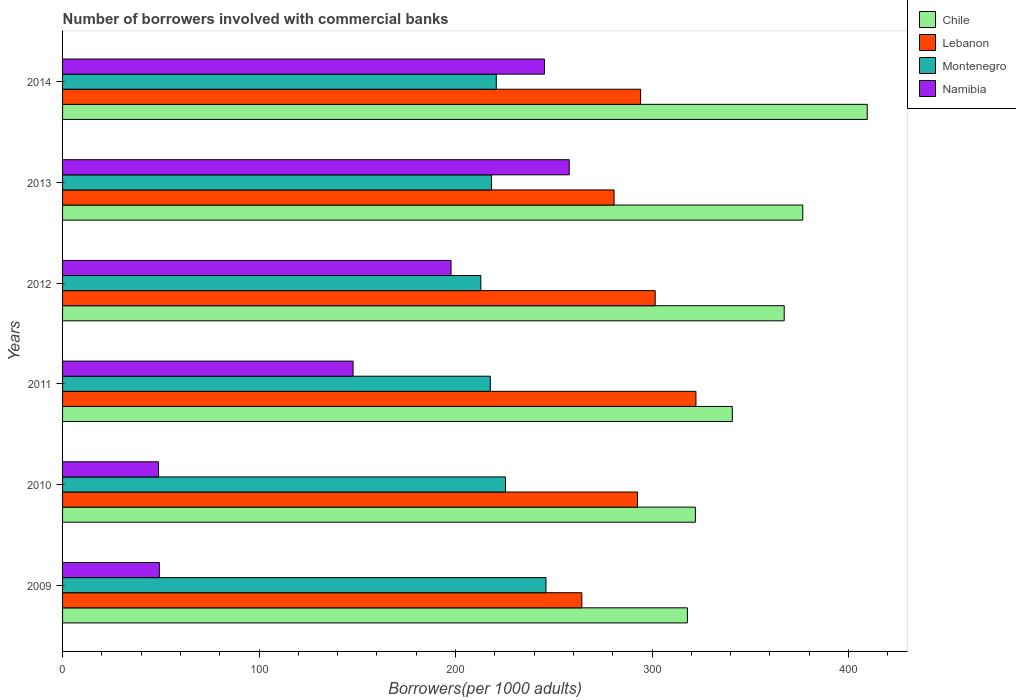How many different coloured bars are there?
Give a very brief answer. 4. Are the number of bars on each tick of the Y-axis equal?
Ensure brevity in your answer.  Yes. How many bars are there on the 2nd tick from the top?
Your answer should be very brief. 4. In how many cases, is the number of bars for a given year not equal to the number of legend labels?
Offer a very short reply. 0. What is the number of borrowers involved with commercial banks in Chile in 2013?
Keep it short and to the point. 376.7. Across all years, what is the maximum number of borrowers involved with commercial banks in Montenegro?
Offer a terse response. 246.02. Across all years, what is the minimum number of borrowers involved with commercial banks in Chile?
Make the answer very short. 317.99. What is the total number of borrowers involved with commercial banks in Lebanon in the graph?
Give a very brief answer. 1755.56. What is the difference between the number of borrowers involved with commercial banks in Montenegro in 2010 and that in 2014?
Provide a short and direct response. 4.68. What is the difference between the number of borrowers involved with commercial banks in Montenegro in 2010 and the number of borrowers involved with commercial banks in Lebanon in 2014?
Give a very brief answer. -68.76. What is the average number of borrowers involved with commercial banks in Montenegro per year?
Keep it short and to the point. 223.5. In the year 2014, what is the difference between the number of borrowers involved with commercial banks in Namibia and number of borrowers involved with commercial banks in Montenegro?
Provide a short and direct response. 24.52. In how many years, is the number of borrowers involved with commercial banks in Lebanon greater than 340 ?
Keep it short and to the point. 0. What is the ratio of the number of borrowers involved with commercial banks in Chile in 2010 to that in 2012?
Offer a very short reply. 0.88. Is the number of borrowers involved with commercial banks in Namibia in 2012 less than that in 2013?
Keep it short and to the point. Yes. Is the difference between the number of borrowers involved with commercial banks in Namibia in 2011 and 2014 greater than the difference between the number of borrowers involved with commercial banks in Montenegro in 2011 and 2014?
Your answer should be compact. No. What is the difference between the highest and the second highest number of borrowers involved with commercial banks in Lebanon?
Your answer should be compact. 20.74. What is the difference between the highest and the lowest number of borrowers involved with commercial banks in Montenegro?
Give a very brief answer. 33.16. Is it the case that in every year, the sum of the number of borrowers involved with commercial banks in Namibia and number of borrowers involved with commercial banks in Montenegro is greater than the sum of number of borrowers involved with commercial banks in Lebanon and number of borrowers involved with commercial banks in Chile?
Ensure brevity in your answer.  No. What does the 3rd bar from the top in 2012 represents?
Provide a succinct answer. Lebanon. What does the 3rd bar from the bottom in 2012 represents?
Provide a short and direct response. Montenegro. Is it the case that in every year, the sum of the number of borrowers involved with commercial banks in Lebanon and number of borrowers involved with commercial banks in Namibia is greater than the number of borrowers involved with commercial banks in Montenegro?
Offer a very short reply. Yes. What is the difference between two consecutive major ticks on the X-axis?
Your answer should be very brief. 100. Are the values on the major ticks of X-axis written in scientific E-notation?
Ensure brevity in your answer.  No. Does the graph contain any zero values?
Provide a short and direct response. No. Where does the legend appear in the graph?
Your response must be concise. Top right. What is the title of the graph?
Make the answer very short. Number of borrowers involved with commercial banks. What is the label or title of the X-axis?
Keep it short and to the point. Borrowers(per 1000 adults). What is the label or title of the Y-axis?
Provide a short and direct response. Years. What is the Borrowers(per 1000 adults) in Chile in 2009?
Keep it short and to the point. 317.99. What is the Borrowers(per 1000 adults) of Lebanon in 2009?
Offer a terse response. 264.25. What is the Borrowers(per 1000 adults) in Montenegro in 2009?
Your response must be concise. 246.02. What is the Borrowers(per 1000 adults) of Namibia in 2009?
Make the answer very short. 49.25. What is the Borrowers(per 1000 adults) in Chile in 2010?
Your answer should be very brief. 322.03. What is the Borrowers(per 1000 adults) of Lebanon in 2010?
Your answer should be compact. 292.58. What is the Borrowers(per 1000 adults) in Montenegro in 2010?
Your answer should be very brief. 225.41. What is the Borrowers(per 1000 adults) in Namibia in 2010?
Keep it short and to the point. 48.85. What is the Borrowers(per 1000 adults) of Chile in 2011?
Make the answer very short. 340.83. What is the Borrowers(per 1000 adults) in Lebanon in 2011?
Offer a very short reply. 322.32. What is the Borrowers(per 1000 adults) in Montenegro in 2011?
Your answer should be compact. 217.69. What is the Borrowers(per 1000 adults) of Namibia in 2011?
Your answer should be very brief. 147.84. What is the Borrowers(per 1000 adults) in Chile in 2012?
Provide a succinct answer. 367.24. What is the Borrowers(per 1000 adults) in Lebanon in 2012?
Offer a terse response. 301.58. What is the Borrowers(per 1000 adults) of Montenegro in 2012?
Provide a succinct answer. 212.85. What is the Borrowers(per 1000 adults) of Namibia in 2012?
Give a very brief answer. 197.69. What is the Borrowers(per 1000 adults) in Chile in 2013?
Your response must be concise. 376.7. What is the Borrowers(per 1000 adults) of Lebanon in 2013?
Give a very brief answer. 280.67. What is the Borrowers(per 1000 adults) in Montenegro in 2013?
Ensure brevity in your answer.  218.3. What is the Borrowers(per 1000 adults) of Namibia in 2013?
Keep it short and to the point. 257.84. What is the Borrowers(per 1000 adults) of Chile in 2014?
Make the answer very short. 409.51. What is the Borrowers(per 1000 adults) in Lebanon in 2014?
Make the answer very short. 294.17. What is the Borrowers(per 1000 adults) of Montenegro in 2014?
Offer a terse response. 220.72. What is the Borrowers(per 1000 adults) of Namibia in 2014?
Provide a short and direct response. 245.24. Across all years, what is the maximum Borrowers(per 1000 adults) of Chile?
Offer a terse response. 409.51. Across all years, what is the maximum Borrowers(per 1000 adults) in Lebanon?
Your response must be concise. 322.32. Across all years, what is the maximum Borrowers(per 1000 adults) of Montenegro?
Your answer should be very brief. 246.02. Across all years, what is the maximum Borrowers(per 1000 adults) of Namibia?
Your answer should be very brief. 257.84. Across all years, what is the minimum Borrowers(per 1000 adults) of Chile?
Give a very brief answer. 317.99. Across all years, what is the minimum Borrowers(per 1000 adults) in Lebanon?
Your answer should be very brief. 264.25. Across all years, what is the minimum Borrowers(per 1000 adults) in Montenegro?
Make the answer very short. 212.85. Across all years, what is the minimum Borrowers(per 1000 adults) of Namibia?
Your answer should be very brief. 48.85. What is the total Borrowers(per 1000 adults) in Chile in the graph?
Your response must be concise. 2134.3. What is the total Borrowers(per 1000 adults) of Lebanon in the graph?
Provide a succinct answer. 1755.56. What is the total Borrowers(per 1000 adults) of Montenegro in the graph?
Offer a terse response. 1340.98. What is the total Borrowers(per 1000 adults) in Namibia in the graph?
Offer a terse response. 946.71. What is the difference between the Borrowers(per 1000 adults) of Chile in 2009 and that in 2010?
Offer a very short reply. -4.04. What is the difference between the Borrowers(per 1000 adults) in Lebanon in 2009 and that in 2010?
Give a very brief answer. -28.33. What is the difference between the Borrowers(per 1000 adults) of Montenegro in 2009 and that in 2010?
Your answer should be compact. 20.61. What is the difference between the Borrowers(per 1000 adults) of Namibia in 2009 and that in 2010?
Provide a short and direct response. 0.4. What is the difference between the Borrowers(per 1000 adults) in Chile in 2009 and that in 2011?
Offer a terse response. -22.84. What is the difference between the Borrowers(per 1000 adults) in Lebanon in 2009 and that in 2011?
Offer a very short reply. -58.07. What is the difference between the Borrowers(per 1000 adults) in Montenegro in 2009 and that in 2011?
Offer a terse response. 28.33. What is the difference between the Borrowers(per 1000 adults) in Namibia in 2009 and that in 2011?
Your answer should be very brief. -98.59. What is the difference between the Borrowers(per 1000 adults) in Chile in 2009 and that in 2012?
Offer a very short reply. -49.25. What is the difference between the Borrowers(per 1000 adults) of Lebanon in 2009 and that in 2012?
Offer a very short reply. -37.33. What is the difference between the Borrowers(per 1000 adults) in Montenegro in 2009 and that in 2012?
Your response must be concise. 33.16. What is the difference between the Borrowers(per 1000 adults) of Namibia in 2009 and that in 2012?
Your answer should be very brief. -148.44. What is the difference between the Borrowers(per 1000 adults) in Chile in 2009 and that in 2013?
Ensure brevity in your answer.  -58.7. What is the difference between the Borrowers(per 1000 adults) in Lebanon in 2009 and that in 2013?
Provide a succinct answer. -16.42. What is the difference between the Borrowers(per 1000 adults) of Montenegro in 2009 and that in 2013?
Keep it short and to the point. 27.72. What is the difference between the Borrowers(per 1000 adults) of Namibia in 2009 and that in 2013?
Your answer should be compact. -208.59. What is the difference between the Borrowers(per 1000 adults) in Chile in 2009 and that in 2014?
Your response must be concise. -91.52. What is the difference between the Borrowers(per 1000 adults) in Lebanon in 2009 and that in 2014?
Your answer should be compact. -29.92. What is the difference between the Borrowers(per 1000 adults) in Montenegro in 2009 and that in 2014?
Offer a terse response. 25.29. What is the difference between the Borrowers(per 1000 adults) of Namibia in 2009 and that in 2014?
Your answer should be very brief. -195.99. What is the difference between the Borrowers(per 1000 adults) in Chile in 2010 and that in 2011?
Your response must be concise. -18.8. What is the difference between the Borrowers(per 1000 adults) of Lebanon in 2010 and that in 2011?
Make the answer very short. -29.74. What is the difference between the Borrowers(per 1000 adults) of Montenegro in 2010 and that in 2011?
Provide a short and direct response. 7.72. What is the difference between the Borrowers(per 1000 adults) in Namibia in 2010 and that in 2011?
Offer a terse response. -99. What is the difference between the Borrowers(per 1000 adults) in Chile in 2010 and that in 2012?
Provide a short and direct response. -45.21. What is the difference between the Borrowers(per 1000 adults) of Lebanon in 2010 and that in 2012?
Give a very brief answer. -9. What is the difference between the Borrowers(per 1000 adults) in Montenegro in 2010 and that in 2012?
Your response must be concise. 12.55. What is the difference between the Borrowers(per 1000 adults) of Namibia in 2010 and that in 2012?
Offer a very short reply. -148.84. What is the difference between the Borrowers(per 1000 adults) in Chile in 2010 and that in 2013?
Ensure brevity in your answer.  -54.66. What is the difference between the Borrowers(per 1000 adults) in Lebanon in 2010 and that in 2013?
Provide a succinct answer. 11.91. What is the difference between the Borrowers(per 1000 adults) of Montenegro in 2010 and that in 2013?
Provide a succinct answer. 7.11. What is the difference between the Borrowers(per 1000 adults) in Namibia in 2010 and that in 2013?
Make the answer very short. -208.99. What is the difference between the Borrowers(per 1000 adults) in Chile in 2010 and that in 2014?
Offer a very short reply. -87.47. What is the difference between the Borrowers(per 1000 adults) in Lebanon in 2010 and that in 2014?
Your answer should be compact. -1.59. What is the difference between the Borrowers(per 1000 adults) of Montenegro in 2010 and that in 2014?
Ensure brevity in your answer.  4.68. What is the difference between the Borrowers(per 1000 adults) of Namibia in 2010 and that in 2014?
Your answer should be very brief. -196.39. What is the difference between the Borrowers(per 1000 adults) of Chile in 2011 and that in 2012?
Your response must be concise. -26.41. What is the difference between the Borrowers(per 1000 adults) in Lebanon in 2011 and that in 2012?
Provide a succinct answer. 20.74. What is the difference between the Borrowers(per 1000 adults) in Montenegro in 2011 and that in 2012?
Offer a very short reply. 4.83. What is the difference between the Borrowers(per 1000 adults) of Namibia in 2011 and that in 2012?
Your answer should be compact. -49.85. What is the difference between the Borrowers(per 1000 adults) in Chile in 2011 and that in 2013?
Keep it short and to the point. -35.86. What is the difference between the Borrowers(per 1000 adults) of Lebanon in 2011 and that in 2013?
Provide a succinct answer. 41.65. What is the difference between the Borrowers(per 1000 adults) in Montenegro in 2011 and that in 2013?
Your answer should be very brief. -0.61. What is the difference between the Borrowers(per 1000 adults) in Namibia in 2011 and that in 2013?
Your answer should be very brief. -110. What is the difference between the Borrowers(per 1000 adults) of Chile in 2011 and that in 2014?
Make the answer very short. -68.67. What is the difference between the Borrowers(per 1000 adults) of Lebanon in 2011 and that in 2014?
Keep it short and to the point. 28.15. What is the difference between the Borrowers(per 1000 adults) in Montenegro in 2011 and that in 2014?
Provide a short and direct response. -3.03. What is the difference between the Borrowers(per 1000 adults) of Namibia in 2011 and that in 2014?
Provide a succinct answer. -97.39. What is the difference between the Borrowers(per 1000 adults) of Chile in 2012 and that in 2013?
Provide a succinct answer. -9.46. What is the difference between the Borrowers(per 1000 adults) of Lebanon in 2012 and that in 2013?
Your response must be concise. 20.91. What is the difference between the Borrowers(per 1000 adults) of Montenegro in 2012 and that in 2013?
Make the answer very short. -5.44. What is the difference between the Borrowers(per 1000 adults) in Namibia in 2012 and that in 2013?
Your answer should be very brief. -60.15. What is the difference between the Borrowers(per 1000 adults) in Chile in 2012 and that in 2014?
Provide a succinct answer. -42.27. What is the difference between the Borrowers(per 1000 adults) in Lebanon in 2012 and that in 2014?
Offer a terse response. 7.41. What is the difference between the Borrowers(per 1000 adults) of Montenegro in 2012 and that in 2014?
Offer a terse response. -7.87. What is the difference between the Borrowers(per 1000 adults) in Namibia in 2012 and that in 2014?
Ensure brevity in your answer.  -47.55. What is the difference between the Borrowers(per 1000 adults) in Chile in 2013 and that in 2014?
Provide a short and direct response. -32.81. What is the difference between the Borrowers(per 1000 adults) of Lebanon in 2013 and that in 2014?
Give a very brief answer. -13.5. What is the difference between the Borrowers(per 1000 adults) in Montenegro in 2013 and that in 2014?
Ensure brevity in your answer.  -2.42. What is the difference between the Borrowers(per 1000 adults) of Namibia in 2013 and that in 2014?
Provide a succinct answer. 12.6. What is the difference between the Borrowers(per 1000 adults) in Chile in 2009 and the Borrowers(per 1000 adults) in Lebanon in 2010?
Make the answer very short. 25.41. What is the difference between the Borrowers(per 1000 adults) of Chile in 2009 and the Borrowers(per 1000 adults) of Montenegro in 2010?
Your response must be concise. 92.59. What is the difference between the Borrowers(per 1000 adults) of Chile in 2009 and the Borrowers(per 1000 adults) of Namibia in 2010?
Your response must be concise. 269.14. What is the difference between the Borrowers(per 1000 adults) in Lebanon in 2009 and the Borrowers(per 1000 adults) in Montenegro in 2010?
Your answer should be compact. 38.84. What is the difference between the Borrowers(per 1000 adults) of Lebanon in 2009 and the Borrowers(per 1000 adults) of Namibia in 2010?
Your response must be concise. 215.4. What is the difference between the Borrowers(per 1000 adults) of Montenegro in 2009 and the Borrowers(per 1000 adults) of Namibia in 2010?
Your answer should be very brief. 197.17. What is the difference between the Borrowers(per 1000 adults) of Chile in 2009 and the Borrowers(per 1000 adults) of Lebanon in 2011?
Ensure brevity in your answer.  -4.33. What is the difference between the Borrowers(per 1000 adults) of Chile in 2009 and the Borrowers(per 1000 adults) of Montenegro in 2011?
Provide a succinct answer. 100.3. What is the difference between the Borrowers(per 1000 adults) of Chile in 2009 and the Borrowers(per 1000 adults) of Namibia in 2011?
Ensure brevity in your answer.  170.15. What is the difference between the Borrowers(per 1000 adults) in Lebanon in 2009 and the Borrowers(per 1000 adults) in Montenegro in 2011?
Offer a very short reply. 46.56. What is the difference between the Borrowers(per 1000 adults) of Lebanon in 2009 and the Borrowers(per 1000 adults) of Namibia in 2011?
Offer a terse response. 116.4. What is the difference between the Borrowers(per 1000 adults) in Montenegro in 2009 and the Borrowers(per 1000 adults) in Namibia in 2011?
Make the answer very short. 98.17. What is the difference between the Borrowers(per 1000 adults) of Chile in 2009 and the Borrowers(per 1000 adults) of Lebanon in 2012?
Ensure brevity in your answer.  16.41. What is the difference between the Borrowers(per 1000 adults) in Chile in 2009 and the Borrowers(per 1000 adults) in Montenegro in 2012?
Make the answer very short. 105.14. What is the difference between the Borrowers(per 1000 adults) of Chile in 2009 and the Borrowers(per 1000 adults) of Namibia in 2012?
Ensure brevity in your answer.  120.3. What is the difference between the Borrowers(per 1000 adults) of Lebanon in 2009 and the Borrowers(per 1000 adults) of Montenegro in 2012?
Make the answer very short. 51.39. What is the difference between the Borrowers(per 1000 adults) in Lebanon in 2009 and the Borrowers(per 1000 adults) in Namibia in 2012?
Ensure brevity in your answer.  66.56. What is the difference between the Borrowers(per 1000 adults) in Montenegro in 2009 and the Borrowers(per 1000 adults) in Namibia in 2012?
Ensure brevity in your answer.  48.33. What is the difference between the Borrowers(per 1000 adults) of Chile in 2009 and the Borrowers(per 1000 adults) of Lebanon in 2013?
Offer a terse response. 37.32. What is the difference between the Borrowers(per 1000 adults) of Chile in 2009 and the Borrowers(per 1000 adults) of Montenegro in 2013?
Provide a succinct answer. 99.69. What is the difference between the Borrowers(per 1000 adults) in Chile in 2009 and the Borrowers(per 1000 adults) in Namibia in 2013?
Ensure brevity in your answer.  60.15. What is the difference between the Borrowers(per 1000 adults) of Lebanon in 2009 and the Borrowers(per 1000 adults) of Montenegro in 2013?
Provide a short and direct response. 45.95. What is the difference between the Borrowers(per 1000 adults) of Lebanon in 2009 and the Borrowers(per 1000 adults) of Namibia in 2013?
Give a very brief answer. 6.41. What is the difference between the Borrowers(per 1000 adults) in Montenegro in 2009 and the Borrowers(per 1000 adults) in Namibia in 2013?
Ensure brevity in your answer.  -11.83. What is the difference between the Borrowers(per 1000 adults) of Chile in 2009 and the Borrowers(per 1000 adults) of Lebanon in 2014?
Ensure brevity in your answer.  23.82. What is the difference between the Borrowers(per 1000 adults) of Chile in 2009 and the Borrowers(per 1000 adults) of Montenegro in 2014?
Offer a terse response. 97.27. What is the difference between the Borrowers(per 1000 adults) of Chile in 2009 and the Borrowers(per 1000 adults) of Namibia in 2014?
Provide a short and direct response. 72.75. What is the difference between the Borrowers(per 1000 adults) in Lebanon in 2009 and the Borrowers(per 1000 adults) in Montenegro in 2014?
Provide a short and direct response. 43.53. What is the difference between the Borrowers(per 1000 adults) in Lebanon in 2009 and the Borrowers(per 1000 adults) in Namibia in 2014?
Your answer should be very brief. 19.01. What is the difference between the Borrowers(per 1000 adults) of Montenegro in 2009 and the Borrowers(per 1000 adults) of Namibia in 2014?
Keep it short and to the point. 0.78. What is the difference between the Borrowers(per 1000 adults) in Chile in 2010 and the Borrowers(per 1000 adults) in Lebanon in 2011?
Offer a terse response. -0.29. What is the difference between the Borrowers(per 1000 adults) in Chile in 2010 and the Borrowers(per 1000 adults) in Montenegro in 2011?
Provide a succinct answer. 104.35. What is the difference between the Borrowers(per 1000 adults) of Chile in 2010 and the Borrowers(per 1000 adults) of Namibia in 2011?
Make the answer very short. 174.19. What is the difference between the Borrowers(per 1000 adults) in Lebanon in 2010 and the Borrowers(per 1000 adults) in Montenegro in 2011?
Make the answer very short. 74.89. What is the difference between the Borrowers(per 1000 adults) of Lebanon in 2010 and the Borrowers(per 1000 adults) of Namibia in 2011?
Make the answer very short. 144.74. What is the difference between the Borrowers(per 1000 adults) in Montenegro in 2010 and the Borrowers(per 1000 adults) in Namibia in 2011?
Ensure brevity in your answer.  77.56. What is the difference between the Borrowers(per 1000 adults) in Chile in 2010 and the Borrowers(per 1000 adults) in Lebanon in 2012?
Your answer should be very brief. 20.45. What is the difference between the Borrowers(per 1000 adults) of Chile in 2010 and the Borrowers(per 1000 adults) of Montenegro in 2012?
Offer a terse response. 109.18. What is the difference between the Borrowers(per 1000 adults) in Chile in 2010 and the Borrowers(per 1000 adults) in Namibia in 2012?
Your response must be concise. 124.34. What is the difference between the Borrowers(per 1000 adults) of Lebanon in 2010 and the Borrowers(per 1000 adults) of Montenegro in 2012?
Your answer should be very brief. 79.73. What is the difference between the Borrowers(per 1000 adults) in Lebanon in 2010 and the Borrowers(per 1000 adults) in Namibia in 2012?
Provide a succinct answer. 94.89. What is the difference between the Borrowers(per 1000 adults) in Montenegro in 2010 and the Borrowers(per 1000 adults) in Namibia in 2012?
Your answer should be very brief. 27.72. What is the difference between the Borrowers(per 1000 adults) in Chile in 2010 and the Borrowers(per 1000 adults) in Lebanon in 2013?
Give a very brief answer. 41.37. What is the difference between the Borrowers(per 1000 adults) in Chile in 2010 and the Borrowers(per 1000 adults) in Montenegro in 2013?
Your answer should be compact. 103.73. What is the difference between the Borrowers(per 1000 adults) of Chile in 2010 and the Borrowers(per 1000 adults) of Namibia in 2013?
Ensure brevity in your answer.  64.19. What is the difference between the Borrowers(per 1000 adults) in Lebanon in 2010 and the Borrowers(per 1000 adults) in Montenegro in 2013?
Give a very brief answer. 74.28. What is the difference between the Borrowers(per 1000 adults) of Lebanon in 2010 and the Borrowers(per 1000 adults) of Namibia in 2013?
Your response must be concise. 34.74. What is the difference between the Borrowers(per 1000 adults) of Montenegro in 2010 and the Borrowers(per 1000 adults) of Namibia in 2013?
Offer a very short reply. -32.44. What is the difference between the Borrowers(per 1000 adults) of Chile in 2010 and the Borrowers(per 1000 adults) of Lebanon in 2014?
Your response must be concise. 27.86. What is the difference between the Borrowers(per 1000 adults) of Chile in 2010 and the Borrowers(per 1000 adults) of Montenegro in 2014?
Offer a very short reply. 101.31. What is the difference between the Borrowers(per 1000 adults) of Chile in 2010 and the Borrowers(per 1000 adults) of Namibia in 2014?
Provide a succinct answer. 76.79. What is the difference between the Borrowers(per 1000 adults) of Lebanon in 2010 and the Borrowers(per 1000 adults) of Montenegro in 2014?
Ensure brevity in your answer.  71.86. What is the difference between the Borrowers(per 1000 adults) in Lebanon in 2010 and the Borrowers(per 1000 adults) in Namibia in 2014?
Your answer should be compact. 47.34. What is the difference between the Borrowers(per 1000 adults) in Montenegro in 2010 and the Borrowers(per 1000 adults) in Namibia in 2014?
Provide a short and direct response. -19.83. What is the difference between the Borrowers(per 1000 adults) of Chile in 2011 and the Borrowers(per 1000 adults) of Lebanon in 2012?
Give a very brief answer. 39.26. What is the difference between the Borrowers(per 1000 adults) of Chile in 2011 and the Borrowers(per 1000 adults) of Montenegro in 2012?
Offer a very short reply. 127.98. What is the difference between the Borrowers(per 1000 adults) of Chile in 2011 and the Borrowers(per 1000 adults) of Namibia in 2012?
Ensure brevity in your answer.  143.14. What is the difference between the Borrowers(per 1000 adults) in Lebanon in 2011 and the Borrowers(per 1000 adults) in Montenegro in 2012?
Your answer should be compact. 109.47. What is the difference between the Borrowers(per 1000 adults) in Lebanon in 2011 and the Borrowers(per 1000 adults) in Namibia in 2012?
Give a very brief answer. 124.63. What is the difference between the Borrowers(per 1000 adults) in Montenegro in 2011 and the Borrowers(per 1000 adults) in Namibia in 2012?
Ensure brevity in your answer.  20. What is the difference between the Borrowers(per 1000 adults) of Chile in 2011 and the Borrowers(per 1000 adults) of Lebanon in 2013?
Ensure brevity in your answer.  60.17. What is the difference between the Borrowers(per 1000 adults) of Chile in 2011 and the Borrowers(per 1000 adults) of Montenegro in 2013?
Ensure brevity in your answer.  122.54. What is the difference between the Borrowers(per 1000 adults) of Chile in 2011 and the Borrowers(per 1000 adults) of Namibia in 2013?
Your answer should be compact. 82.99. What is the difference between the Borrowers(per 1000 adults) of Lebanon in 2011 and the Borrowers(per 1000 adults) of Montenegro in 2013?
Offer a very short reply. 104.02. What is the difference between the Borrowers(per 1000 adults) in Lebanon in 2011 and the Borrowers(per 1000 adults) in Namibia in 2013?
Give a very brief answer. 64.48. What is the difference between the Borrowers(per 1000 adults) in Montenegro in 2011 and the Borrowers(per 1000 adults) in Namibia in 2013?
Give a very brief answer. -40.16. What is the difference between the Borrowers(per 1000 adults) of Chile in 2011 and the Borrowers(per 1000 adults) of Lebanon in 2014?
Give a very brief answer. 46.66. What is the difference between the Borrowers(per 1000 adults) in Chile in 2011 and the Borrowers(per 1000 adults) in Montenegro in 2014?
Your answer should be compact. 120.11. What is the difference between the Borrowers(per 1000 adults) in Chile in 2011 and the Borrowers(per 1000 adults) in Namibia in 2014?
Offer a very short reply. 95.6. What is the difference between the Borrowers(per 1000 adults) of Lebanon in 2011 and the Borrowers(per 1000 adults) of Montenegro in 2014?
Keep it short and to the point. 101.6. What is the difference between the Borrowers(per 1000 adults) in Lebanon in 2011 and the Borrowers(per 1000 adults) in Namibia in 2014?
Give a very brief answer. 77.08. What is the difference between the Borrowers(per 1000 adults) of Montenegro in 2011 and the Borrowers(per 1000 adults) of Namibia in 2014?
Your answer should be compact. -27.55. What is the difference between the Borrowers(per 1000 adults) in Chile in 2012 and the Borrowers(per 1000 adults) in Lebanon in 2013?
Your answer should be very brief. 86.57. What is the difference between the Borrowers(per 1000 adults) of Chile in 2012 and the Borrowers(per 1000 adults) of Montenegro in 2013?
Offer a terse response. 148.94. What is the difference between the Borrowers(per 1000 adults) in Chile in 2012 and the Borrowers(per 1000 adults) in Namibia in 2013?
Keep it short and to the point. 109.4. What is the difference between the Borrowers(per 1000 adults) of Lebanon in 2012 and the Borrowers(per 1000 adults) of Montenegro in 2013?
Your answer should be very brief. 83.28. What is the difference between the Borrowers(per 1000 adults) of Lebanon in 2012 and the Borrowers(per 1000 adults) of Namibia in 2013?
Offer a terse response. 43.74. What is the difference between the Borrowers(per 1000 adults) of Montenegro in 2012 and the Borrowers(per 1000 adults) of Namibia in 2013?
Keep it short and to the point. -44.99. What is the difference between the Borrowers(per 1000 adults) of Chile in 2012 and the Borrowers(per 1000 adults) of Lebanon in 2014?
Ensure brevity in your answer.  73.07. What is the difference between the Borrowers(per 1000 adults) of Chile in 2012 and the Borrowers(per 1000 adults) of Montenegro in 2014?
Ensure brevity in your answer.  146.52. What is the difference between the Borrowers(per 1000 adults) in Chile in 2012 and the Borrowers(per 1000 adults) in Namibia in 2014?
Your response must be concise. 122. What is the difference between the Borrowers(per 1000 adults) in Lebanon in 2012 and the Borrowers(per 1000 adults) in Montenegro in 2014?
Give a very brief answer. 80.86. What is the difference between the Borrowers(per 1000 adults) of Lebanon in 2012 and the Borrowers(per 1000 adults) of Namibia in 2014?
Your answer should be very brief. 56.34. What is the difference between the Borrowers(per 1000 adults) of Montenegro in 2012 and the Borrowers(per 1000 adults) of Namibia in 2014?
Keep it short and to the point. -32.38. What is the difference between the Borrowers(per 1000 adults) in Chile in 2013 and the Borrowers(per 1000 adults) in Lebanon in 2014?
Your answer should be very brief. 82.53. What is the difference between the Borrowers(per 1000 adults) of Chile in 2013 and the Borrowers(per 1000 adults) of Montenegro in 2014?
Make the answer very short. 155.97. What is the difference between the Borrowers(per 1000 adults) of Chile in 2013 and the Borrowers(per 1000 adults) of Namibia in 2014?
Provide a succinct answer. 131.46. What is the difference between the Borrowers(per 1000 adults) of Lebanon in 2013 and the Borrowers(per 1000 adults) of Montenegro in 2014?
Make the answer very short. 59.95. What is the difference between the Borrowers(per 1000 adults) in Lebanon in 2013 and the Borrowers(per 1000 adults) in Namibia in 2014?
Your answer should be very brief. 35.43. What is the difference between the Borrowers(per 1000 adults) in Montenegro in 2013 and the Borrowers(per 1000 adults) in Namibia in 2014?
Your answer should be very brief. -26.94. What is the average Borrowers(per 1000 adults) in Chile per year?
Ensure brevity in your answer.  355.72. What is the average Borrowers(per 1000 adults) of Lebanon per year?
Offer a very short reply. 292.59. What is the average Borrowers(per 1000 adults) in Montenegro per year?
Your answer should be compact. 223.5. What is the average Borrowers(per 1000 adults) in Namibia per year?
Make the answer very short. 157.79. In the year 2009, what is the difference between the Borrowers(per 1000 adults) of Chile and Borrowers(per 1000 adults) of Lebanon?
Offer a terse response. 53.74. In the year 2009, what is the difference between the Borrowers(per 1000 adults) in Chile and Borrowers(per 1000 adults) in Montenegro?
Keep it short and to the point. 71.98. In the year 2009, what is the difference between the Borrowers(per 1000 adults) in Chile and Borrowers(per 1000 adults) in Namibia?
Make the answer very short. 268.74. In the year 2009, what is the difference between the Borrowers(per 1000 adults) of Lebanon and Borrowers(per 1000 adults) of Montenegro?
Make the answer very short. 18.23. In the year 2009, what is the difference between the Borrowers(per 1000 adults) of Lebanon and Borrowers(per 1000 adults) of Namibia?
Your answer should be very brief. 215. In the year 2009, what is the difference between the Borrowers(per 1000 adults) of Montenegro and Borrowers(per 1000 adults) of Namibia?
Your response must be concise. 196.77. In the year 2010, what is the difference between the Borrowers(per 1000 adults) of Chile and Borrowers(per 1000 adults) of Lebanon?
Keep it short and to the point. 29.45. In the year 2010, what is the difference between the Borrowers(per 1000 adults) in Chile and Borrowers(per 1000 adults) in Montenegro?
Ensure brevity in your answer.  96.63. In the year 2010, what is the difference between the Borrowers(per 1000 adults) of Chile and Borrowers(per 1000 adults) of Namibia?
Offer a very short reply. 273.18. In the year 2010, what is the difference between the Borrowers(per 1000 adults) of Lebanon and Borrowers(per 1000 adults) of Montenegro?
Your answer should be very brief. 67.18. In the year 2010, what is the difference between the Borrowers(per 1000 adults) of Lebanon and Borrowers(per 1000 adults) of Namibia?
Give a very brief answer. 243.73. In the year 2010, what is the difference between the Borrowers(per 1000 adults) of Montenegro and Borrowers(per 1000 adults) of Namibia?
Provide a short and direct response. 176.56. In the year 2011, what is the difference between the Borrowers(per 1000 adults) in Chile and Borrowers(per 1000 adults) in Lebanon?
Your response must be concise. 18.51. In the year 2011, what is the difference between the Borrowers(per 1000 adults) of Chile and Borrowers(per 1000 adults) of Montenegro?
Provide a short and direct response. 123.15. In the year 2011, what is the difference between the Borrowers(per 1000 adults) of Chile and Borrowers(per 1000 adults) of Namibia?
Your answer should be very brief. 192.99. In the year 2011, what is the difference between the Borrowers(per 1000 adults) of Lebanon and Borrowers(per 1000 adults) of Montenegro?
Your answer should be compact. 104.63. In the year 2011, what is the difference between the Borrowers(per 1000 adults) of Lebanon and Borrowers(per 1000 adults) of Namibia?
Give a very brief answer. 174.48. In the year 2011, what is the difference between the Borrowers(per 1000 adults) of Montenegro and Borrowers(per 1000 adults) of Namibia?
Ensure brevity in your answer.  69.84. In the year 2012, what is the difference between the Borrowers(per 1000 adults) in Chile and Borrowers(per 1000 adults) in Lebanon?
Your response must be concise. 65.66. In the year 2012, what is the difference between the Borrowers(per 1000 adults) in Chile and Borrowers(per 1000 adults) in Montenegro?
Give a very brief answer. 154.38. In the year 2012, what is the difference between the Borrowers(per 1000 adults) in Chile and Borrowers(per 1000 adults) in Namibia?
Your answer should be very brief. 169.55. In the year 2012, what is the difference between the Borrowers(per 1000 adults) of Lebanon and Borrowers(per 1000 adults) of Montenegro?
Offer a very short reply. 88.72. In the year 2012, what is the difference between the Borrowers(per 1000 adults) of Lebanon and Borrowers(per 1000 adults) of Namibia?
Make the answer very short. 103.89. In the year 2012, what is the difference between the Borrowers(per 1000 adults) in Montenegro and Borrowers(per 1000 adults) in Namibia?
Your response must be concise. 15.16. In the year 2013, what is the difference between the Borrowers(per 1000 adults) in Chile and Borrowers(per 1000 adults) in Lebanon?
Offer a very short reply. 96.03. In the year 2013, what is the difference between the Borrowers(per 1000 adults) in Chile and Borrowers(per 1000 adults) in Montenegro?
Make the answer very short. 158.4. In the year 2013, what is the difference between the Borrowers(per 1000 adults) in Chile and Borrowers(per 1000 adults) in Namibia?
Your response must be concise. 118.85. In the year 2013, what is the difference between the Borrowers(per 1000 adults) of Lebanon and Borrowers(per 1000 adults) of Montenegro?
Your response must be concise. 62.37. In the year 2013, what is the difference between the Borrowers(per 1000 adults) of Lebanon and Borrowers(per 1000 adults) of Namibia?
Offer a very short reply. 22.82. In the year 2013, what is the difference between the Borrowers(per 1000 adults) in Montenegro and Borrowers(per 1000 adults) in Namibia?
Make the answer very short. -39.54. In the year 2014, what is the difference between the Borrowers(per 1000 adults) of Chile and Borrowers(per 1000 adults) of Lebanon?
Your answer should be very brief. 115.34. In the year 2014, what is the difference between the Borrowers(per 1000 adults) of Chile and Borrowers(per 1000 adults) of Montenegro?
Your answer should be compact. 188.79. In the year 2014, what is the difference between the Borrowers(per 1000 adults) in Chile and Borrowers(per 1000 adults) in Namibia?
Make the answer very short. 164.27. In the year 2014, what is the difference between the Borrowers(per 1000 adults) in Lebanon and Borrowers(per 1000 adults) in Montenegro?
Your answer should be very brief. 73.45. In the year 2014, what is the difference between the Borrowers(per 1000 adults) of Lebanon and Borrowers(per 1000 adults) of Namibia?
Offer a very short reply. 48.93. In the year 2014, what is the difference between the Borrowers(per 1000 adults) in Montenegro and Borrowers(per 1000 adults) in Namibia?
Offer a very short reply. -24.52. What is the ratio of the Borrowers(per 1000 adults) in Chile in 2009 to that in 2010?
Make the answer very short. 0.99. What is the ratio of the Borrowers(per 1000 adults) in Lebanon in 2009 to that in 2010?
Provide a succinct answer. 0.9. What is the ratio of the Borrowers(per 1000 adults) in Montenegro in 2009 to that in 2010?
Your answer should be compact. 1.09. What is the ratio of the Borrowers(per 1000 adults) in Namibia in 2009 to that in 2010?
Offer a terse response. 1.01. What is the ratio of the Borrowers(per 1000 adults) of Chile in 2009 to that in 2011?
Provide a succinct answer. 0.93. What is the ratio of the Borrowers(per 1000 adults) of Lebanon in 2009 to that in 2011?
Provide a succinct answer. 0.82. What is the ratio of the Borrowers(per 1000 adults) in Montenegro in 2009 to that in 2011?
Offer a terse response. 1.13. What is the ratio of the Borrowers(per 1000 adults) of Namibia in 2009 to that in 2011?
Provide a succinct answer. 0.33. What is the ratio of the Borrowers(per 1000 adults) of Chile in 2009 to that in 2012?
Ensure brevity in your answer.  0.87. What is the ratio of the Borrowers(per 1000 adults) in Lebanon in 2009 to that in 2012?
Your answer should be very brief. 0.88. What is the ratio of the Borrowers(per 1000 adults) in Montenegro in 2009 to that in 2012?
Give a very brief answer. 1.16. What is the ratio of the Borrowers(per 1000 adults) in Namibia in 2009 to that in 2012?
Your answer should be very brief. 0.25. What is the ratio of the Borrowers(per 1000 adults) of Chile in 2009 to that in 2013?
Offer a very short reply. 0.84. What is the ratio of the Borrowers(per 1000 adults) in Lebanon in 2009 to that in 2013?
Provide a succinct answer. 0.94. What is the ratio of the Borrowers(per 1000 adults) of Montenegro in 2009 to that in 2013?
Provide a short and direct response. 1.13. What is the ratio of the Borrowers(per 1000 adults) of Namibia in 2009 to that in 2013?
Provide a succinct answer. 0.19. What is the ratio of the Borrowers(per 1000 adults) of Chile in 2009 to that in 2014?
Provide a short and direct response. 0.78. What is the ratio of the Borrowers(per 1000 adults) of Lebanon in 2009 to that in 2014?
Offer a very short reply. 0.9. What is the ratio of the Borrowers(per 1000 adults) of Montenegro in 2009 to that in 2014?
Your answer should be very brief. 1.11. What is the ratio of the Borrowers(per 1000 adults) of Namibia in 2009 to that in 2014?
Provide a succinct answer. 0.2. What is the ratio of the Borrowers(per 1000 adults) in Chile in 2010 to that in 2011?
Give a very brief answer. 0.94. What is the ratio of the Borrowers(per 1000 adults) in Lebanon in 2010 to that in 2011?
Give a very brief answer. 0.91. What is the ratio of the Borrowers(per 1000 adults) in Montenegro in 2010 to that in 2011?
Provide a short and direct response. 1.04. What is the ratio of the Borrowers(per 1000 adults) of Namibia in 2010 to that in 2011?
Your answer should be very brief. 0.33. What is the ratio of the Borrowers(per 1000 adults) in Chile in 2010 to that in 2012?
Provide a short and direct response. 0.88. What is the ratio of the Borrowers(per 1000 adults) in Lebanon in 2010 to that in 2012?
Your answer should be compact. 0.97. What is the ratio of the Borrowers(per 1000 adults) of Montenegro in 2010 to that in 2012?
Offer a terse response. 1.06. What is the ratio of the Borrowers(per 1000 adults) of Namibia in 2010 to that in 2012?
Your answer should be very brief. 0.25. What is the ratio of the Borrowers(per 1000 adults) of Chile in 2010 to that in 2013?
Make the answer very short. 0.85. What is the ratio of the Borrowers(per 1000 adults) of Lebanon in 2010 to that in 2013?
Give a very brief answer. 1.04. What is the ratio of the Borrowers(per 1000 adults) in Montenegro in 2010 to that in 2013?
Your response must be concise. 1.03. What is the ratio of the Borrowers(per 1000 adults) in Namibia in 2010 to that in 2013?
Make the answer very short. 0.19. What is the ratio of the Borrowers(per 1000 adults) in Chile in 2010 to that in 2014?
Your answer should be compact. 0.79. What is the ratio of the Borrowers(per 1000 adults) of Montenegro in 2010 to that in 2014?
Provide a short and direct response. 1.02. What is the ratio of the Borrowers(per 1000 adults) of Namibia in 2010 to that in 2014?
Ensure brevity in your answer.  0.2. What is the ratio of the Borrowers(per 1000 adults) in Chile in 2011 to that in 2012?
Your answer should be compact. 0.93. What is the ratio of the Borrowers(per 1000 adults) in Lebanon in 2011 to that in 2012?
Offer a very short reply. 1.07. What is the ratio of the Borrowers(per 1000 adults) of Montenegro in 2011 to that in 2012?
Your answer should be compact. 1.02. What is the ratio of the Borrowers(per 1000 adults) of Namibia in 2011 to that in 2012?
Your answer should be very brief. 0.75. What is the ratio of the Borrowers(per 1000 adults) in Chile in 2011 to that in 2013?
Your answer should be compact. 0.9. What is the ratio of the Borrowers(per 1000 adults) in Lebanon in 2011 to that in 2013?
Offer a very short reply. 1.15. What is the ratio of the Borrowers(per 1000 adults) of Montenegro in 2011 to that in 2013?
Your response must be concise. 1. What is the ratio of the Borrowers(per 1000 adults) of Namibia in 2011 to that in 2013?
Ensure brevity in your answer.  0.57. What is the ratio of the Borrowers(per 1000 adults) in Chile in 2011 to that in 2014?
Give a very brief answer. 0.83. What is the ratio of the Borrowers(per 1000 adults) of Lebanon in 2011 to that in 2014?
Your response must be concise. 1.1. What is the ratio of the Borrowers(per 1000 adults) in Montenegro in 2011 to that in 2014?
Your response must be concise. 0.99. What is the ratio of the Borrowers(per 1000 adults) of Namibia in 2011 to that in 2014?
Offer a terse response. 0.6. What is the ratio of the Borrowers(per 1000 adults) in Chile in 2012 to that in 2013?
Keep it short and to the point. 0.97. What is the ratio of the Borrowers(per 1000 adults) of Lebanon in 2012 to that in 2013?
Your answer should be very brief. 1.07. What is the ratio of the Borrowers(per 1000 adults) of Montenegro in 2012 to that in 2013?
Your answer should be compact. 0.98. What is the ratio of the Borrowers(per 1000 adults) of Namibia in 2012 to that in 2013?
Provide a succinct answer. 0.77. What is the ratio of the Borrowers(per 1000 adults) in Chile in 2012 to that in 2014?
Offer a terse response. 0.9. What is the ratio of the Borrowers(per 1000 adults) of Lebanon in 2012 to that in 2014?
Provide a succinct answer. 1.03. What is the ratio of the Borrowers(per 1000 adults) in Montenegro in 2012 to that in 2014?
Make the answer very short. 0.96. What is the ratio of the Borrowers(per 1000 adults) in Namibia in 2012 to that in 2014?
Offer a terse response. 0.81. What is the ratio of the Borrowers(per 1000 adults) in Chile in 2013 to that in 2014?
Keep it short and to the point. 0.92. What is the ratio of the Borrowers(per 1000 adults) in Lebanon in 2013 to that in 2014?
Provide a succinct answer. 0.95. What is the ratio of the Borrowers(per 1000 adults) of Namibia in 2013 to that in 2014?
Provide a succinct answer. 1.05. What is the difference between the highest and the second highest Borrowers(per 1000 adults) of Chile?
Keep it short and to the point. 32.81. What is the difference between the highest and the second highest Borrowers(per 1000 adults) in Lebanon?
Provide a succinct answer. 20.74. What is the difference between the highest and the second highest Borrowers(per 1000 adults) of Montenegro?
Offer a very short reply. 20.61. What is the difference between the highest and the second highest Borrowers(per 1000 adults) of Namibia?
Provide a succinct answer. 12.6. What is the difference between the highest and the lowest Borrowers(per 1000 adults) of Chile?
Your response must be concise. 91.52. What is the difference between the highest and the lowest Borrowers(per 1000 adults) of Lebanon?
Give a very brief answer. 58.07. What is the difference between the highest and the lowest Borrowers(per 1000 adults) in Montenegro?
Your answer should be compact. 33.16. What is the difference between the highest and the lowest Borrowers(per 1000 adults) of Namibia?
Offer a very short reply. 208.99. 